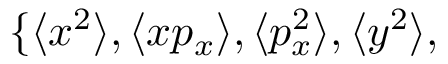Convert formula to latex. <formula><loc_0><loc_0><loc_500><loc_500>\{ \langle x ^ { 2 } \rangle , \langle x p _ { x } \rangle , \langle p _ { x } ^ { 2 } \rangle , \langle y ^ { 2 } \rangle ,</formula> 